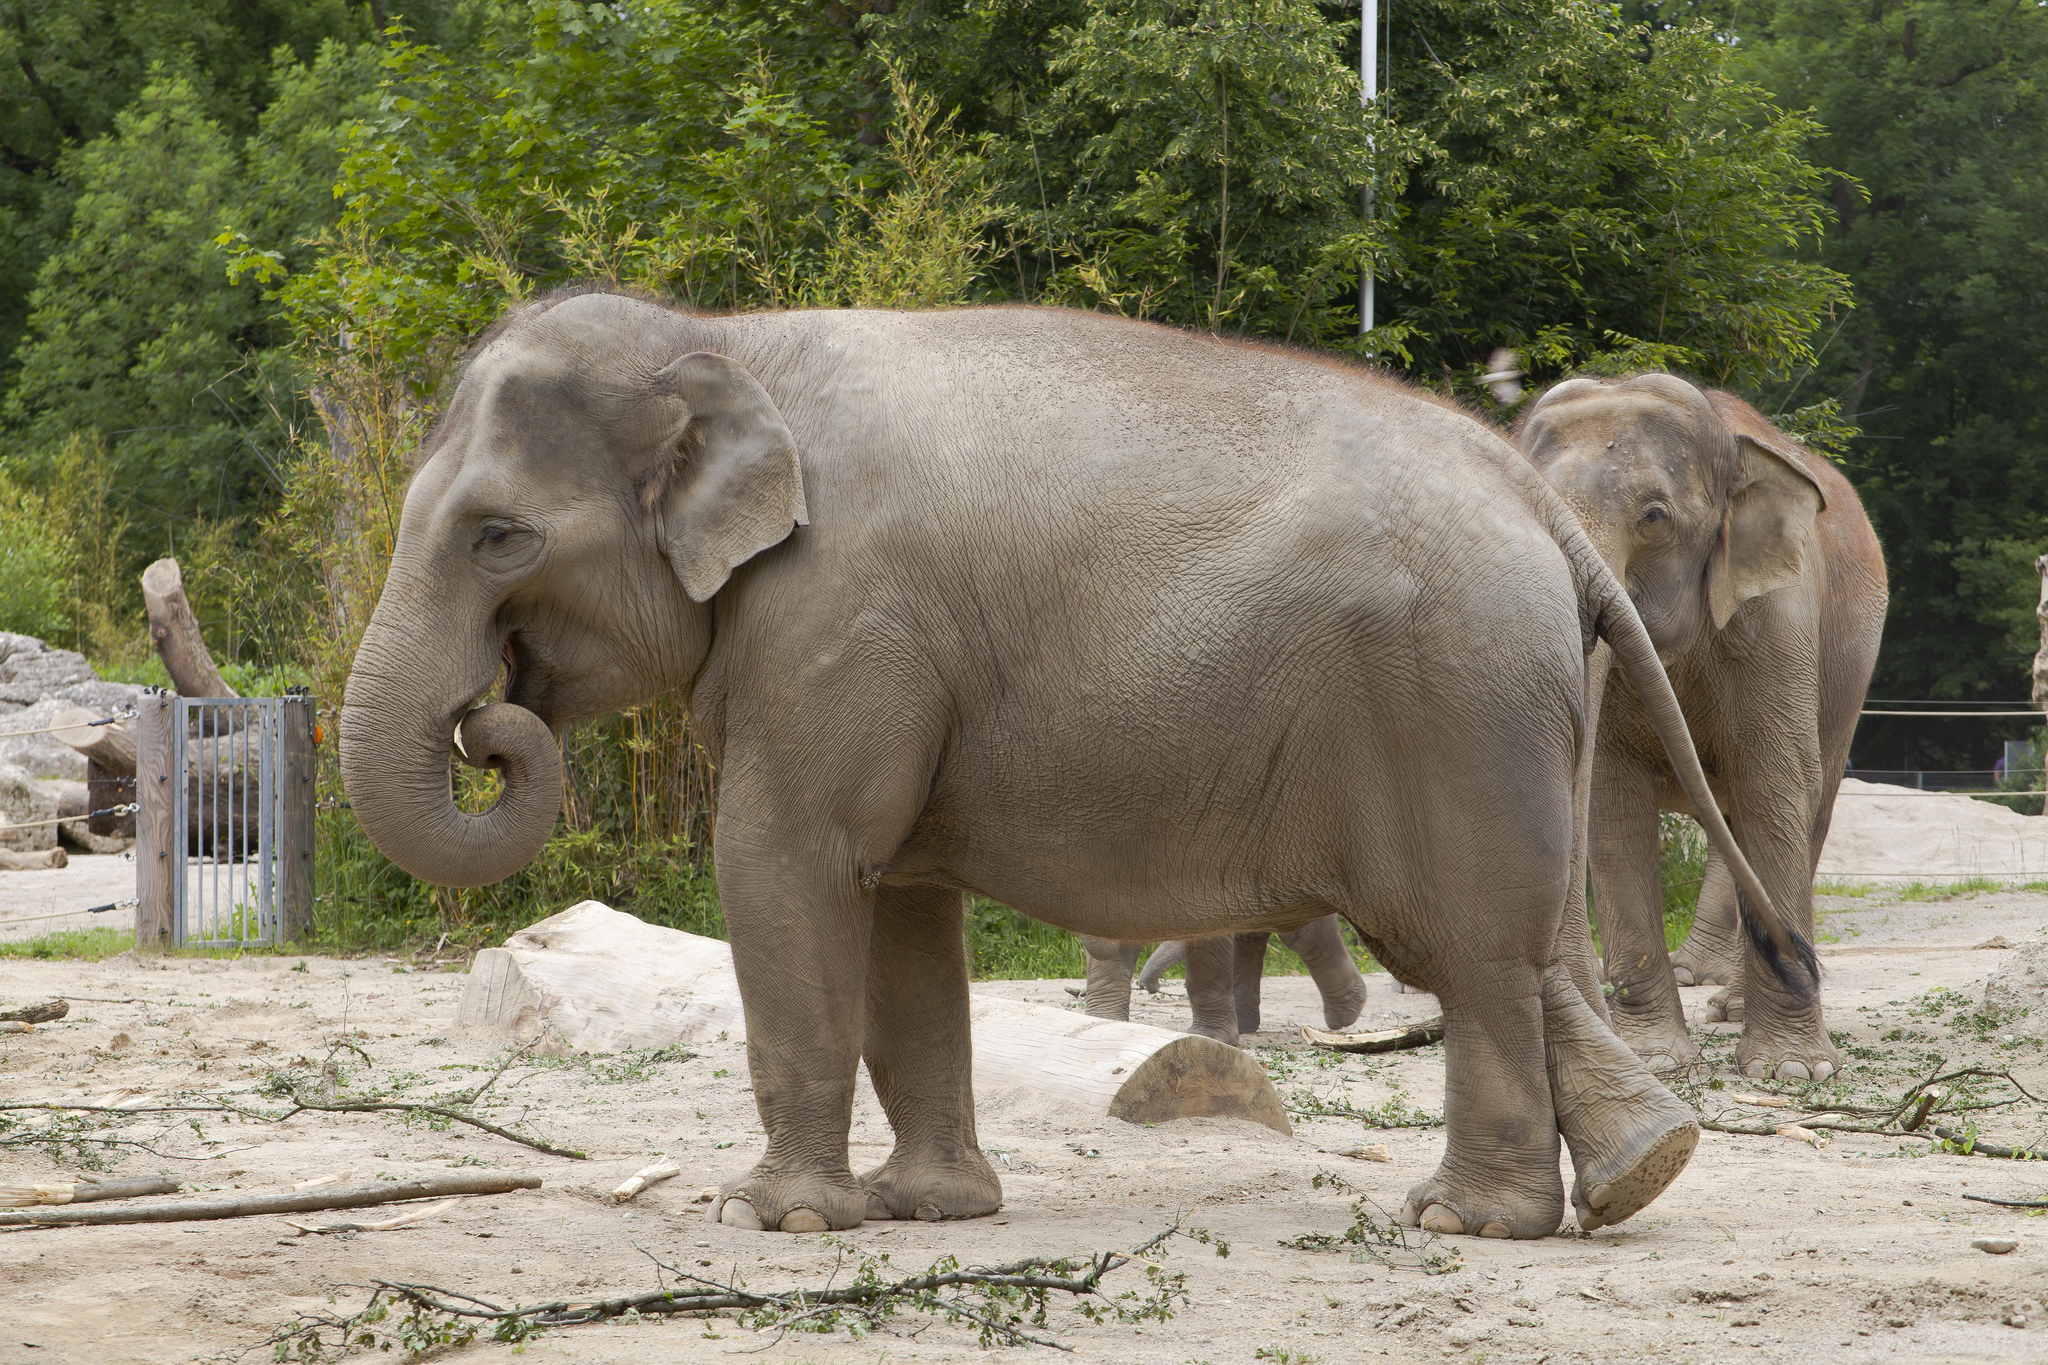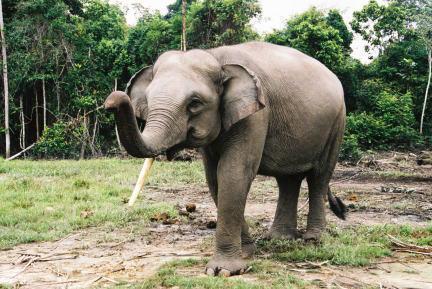The first image is the image on the left, the second image is the image on the right. For the images shown, is this caption "An image includes exactly one elephant, which has an upraised, curled trunk." true? Answer yes or no. Yes. The first image is the image on the left, the second image is the image on the right. Considering the images on both sides, is "A single elephant is standing in one of the images." valid? Answer yes or no. Yes. 